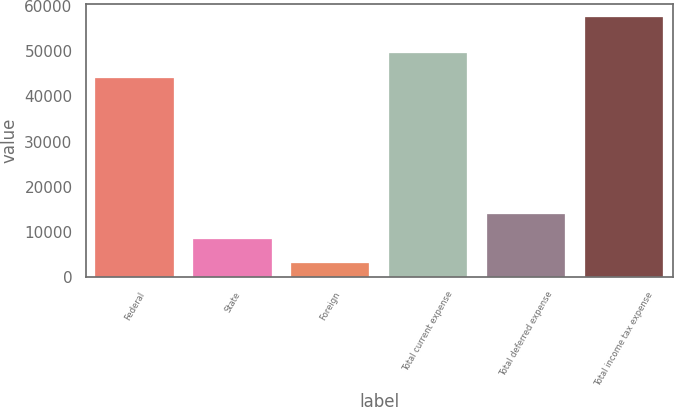<chart> <loc_0><loc_0><loc_500><loc_500><bar_chart><fcel>Federal<fcel>State<fcel>Foreign<fcel>Total current expense<fcel>Total deferred expense<fcel>Total income tax expense<nl><fcel>44139<fcel>8453.6<fcel>2987<fcel>49605.6<fcel>13920.2<fcel>57653<nl></chart> 